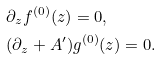<formula> <loc_0><loc_0><loc_500><loc_500>& \partial _ { z } f ^ { ( 0 ) } ( z ) = 0 , \\ & ( \partial _ { z } + A ^ { \prime } ) g ^ { ( 0 ) } ( z ) = 0 .</formula> 